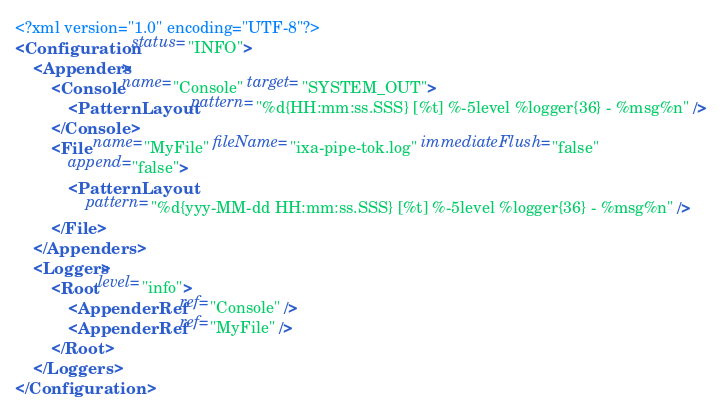Convert code to text. <code><loc_0><loc_0><loc_500><loc_500><_XML_><?xml version="1.0" encoding="UTF-8"?>
<Configuration status="INFO">
	<Appenders>
		<Console name="Console" target="SYSTEM_OUT">
			<PatternLayout pattern="%d{HH:mm:ss.SSS} [%t] %-5level %logger{36} - %msg%n" />
		</Console>
		<File name="MyFile" fileName="ixa-pipe-tok.log" immediateFlush="false"
			append="false">
			<PatternLayout
				pattern="%d{yyy-MM-dd HH:mm:ss.SSS} [%t] %-5level %logger{36} - %msg%n" />
		</File>
	</Appenders>
	<Loggers>
		<Root level="info">
			<AppenderRef ref="Console" />
			<AppenderRef ref="MyFile" />
		</Root>
	</Loggers>
</Configuration></code> 